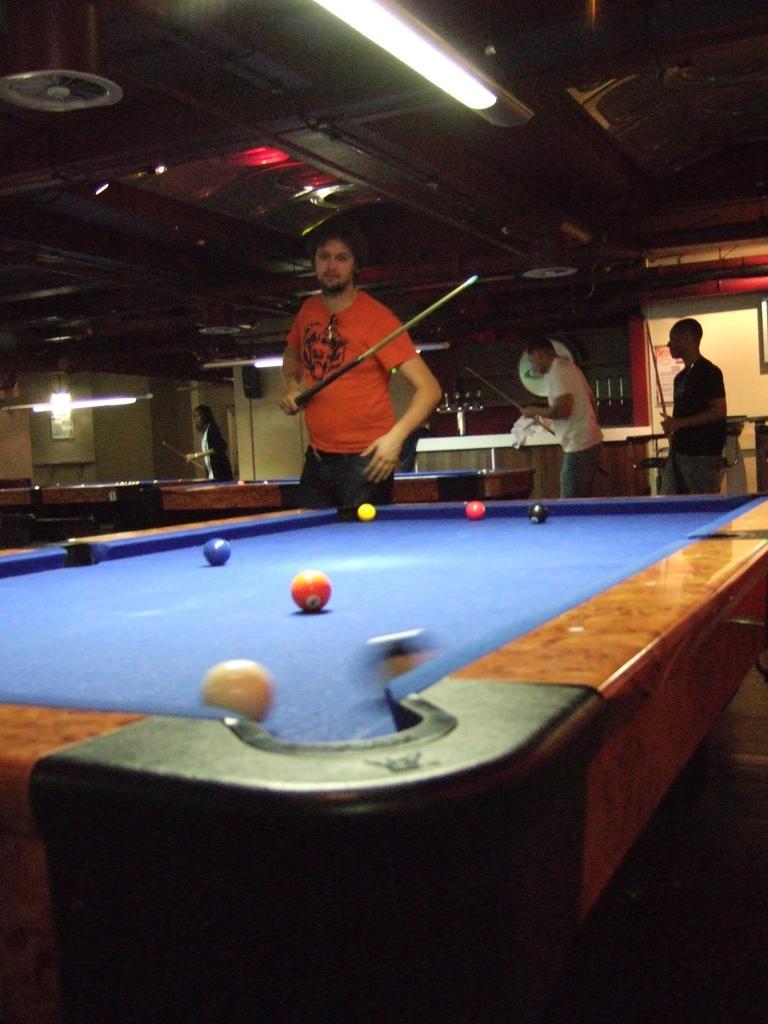How would you summarize this image in a sentence or two? This is a picture taken in a room, there are group of people standing on the floor and there are playing the snooker game. The man in orange t shirt holding a stick. On top of them there is a light. 